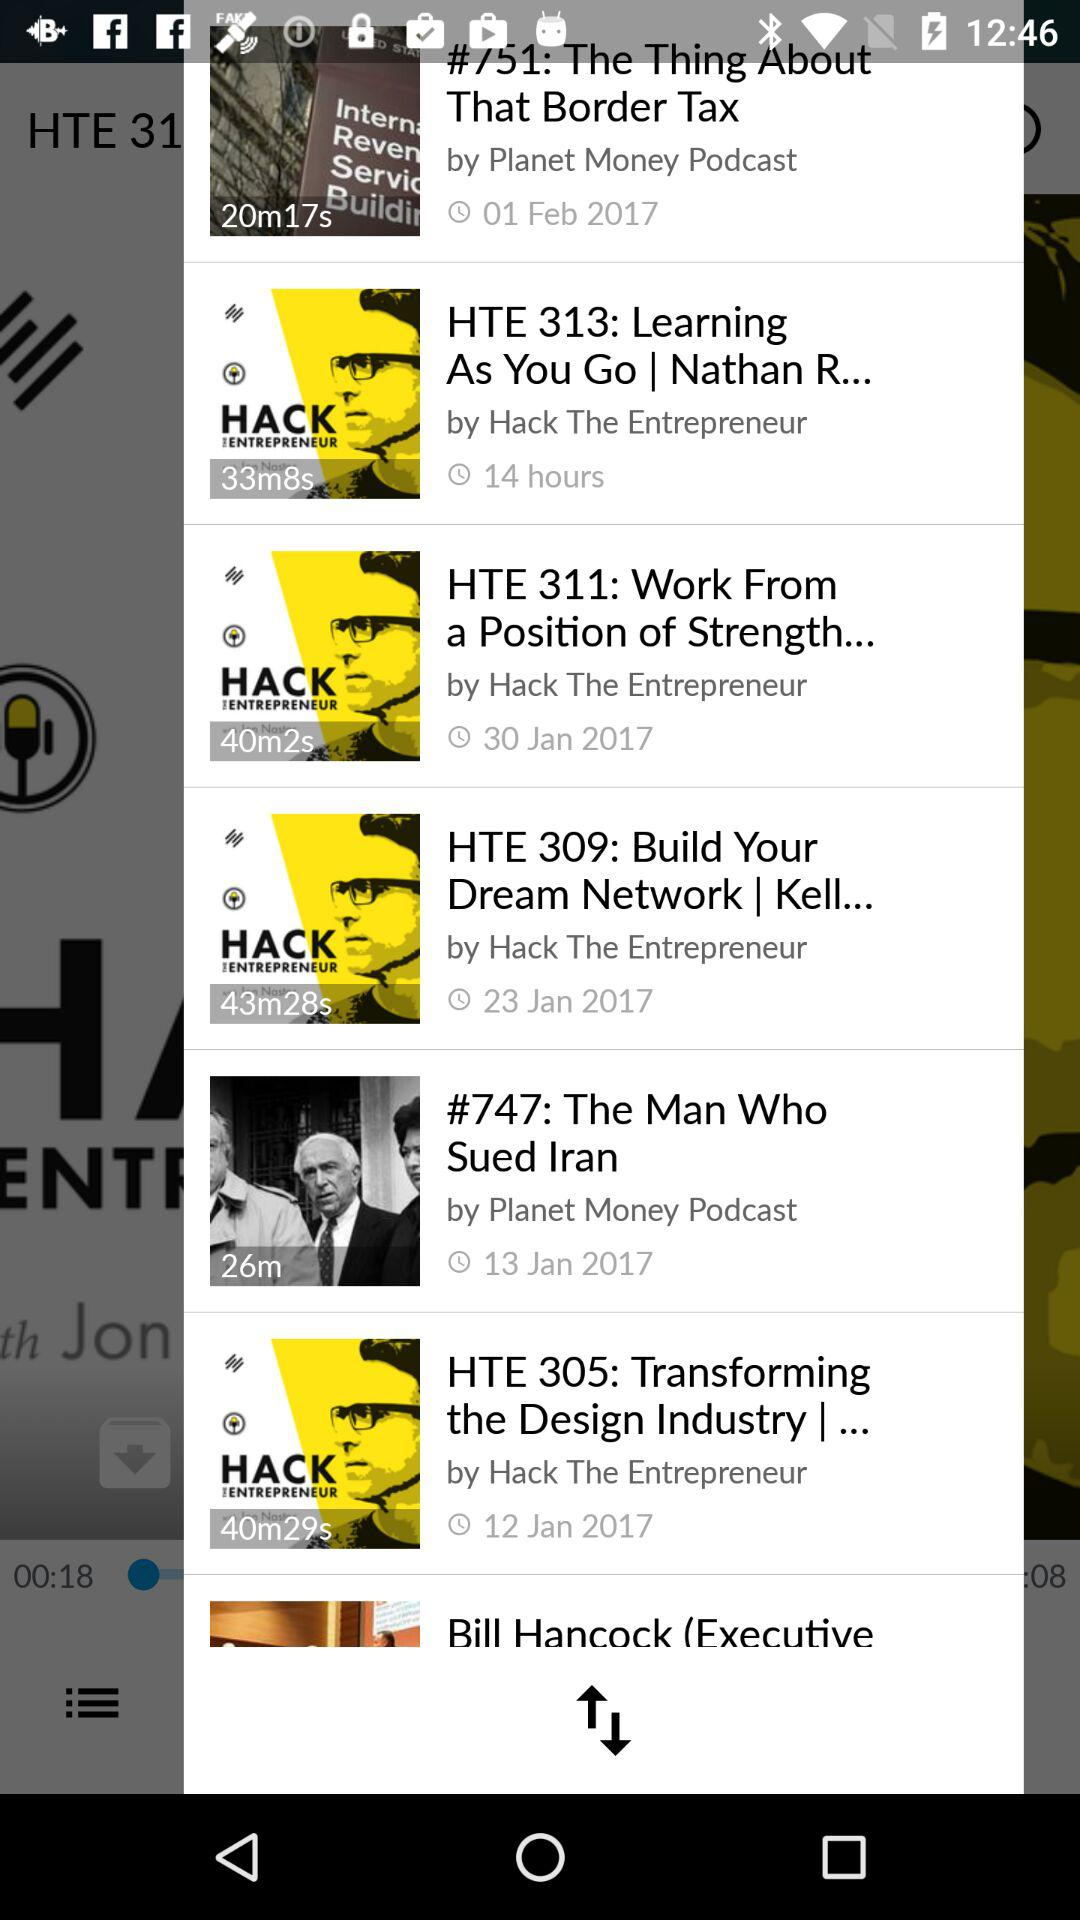What is the duration of "The Man Who Sued Iran"? The duration of "The Man Who Sued Iran" is 26 minutes. 